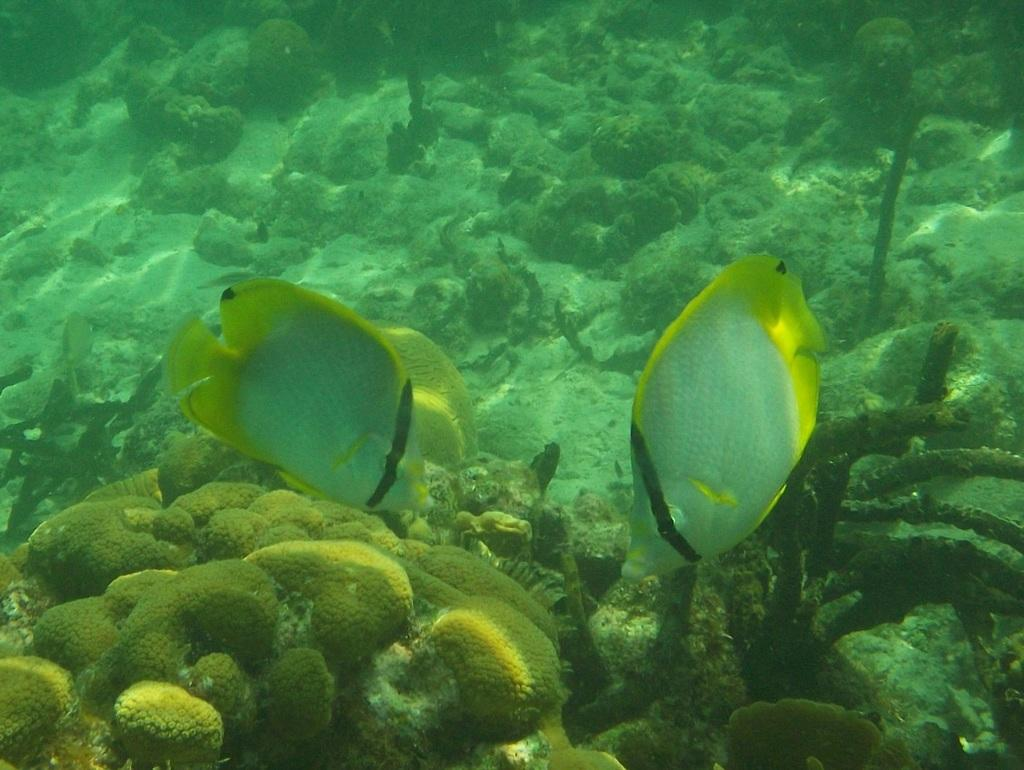Where was the image taken? The image was taken underwater. What can be seen swimming in the image? There are two fishes in the image. What type of environment is visible in the image? There are many plants visible in the image. How many clocks can be seen hanging on the plants in the image? There are no clocks visible in the image; it was taken underwater and features two fishes and many plants. 